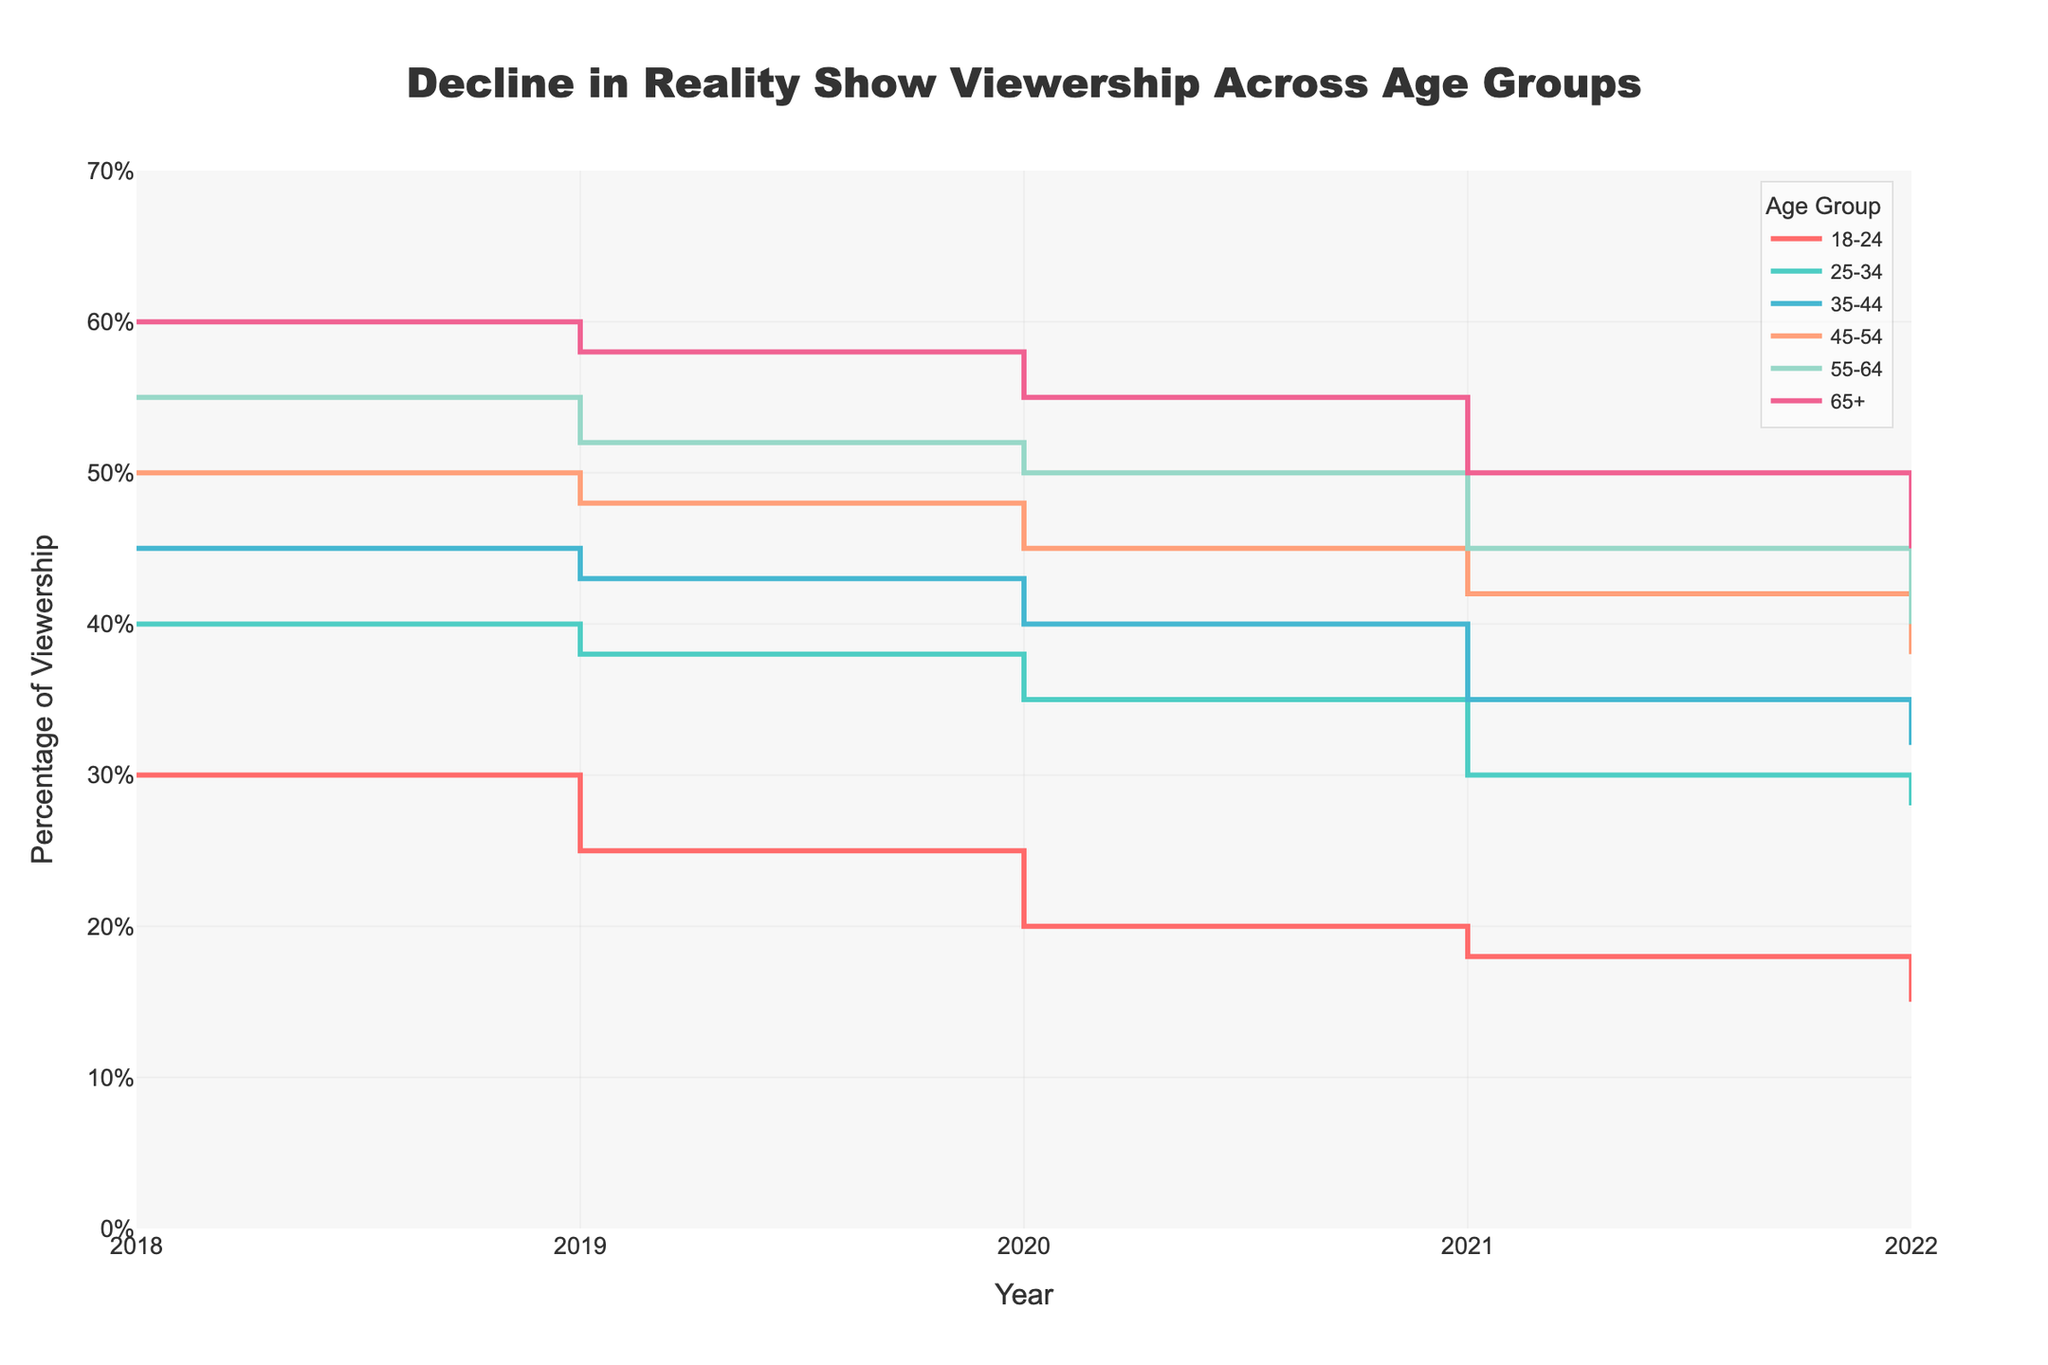What is the title of the figure? The title is located at the top center of the figure.
Answer: Decline in Reality Show Viewership Across Age Groups Which age group had the highest viewership of reality shows in 2018? By examining the data points from 2018, the highest percentage value on the y-axis corresponds to the 65+ age group.
Answer: 65+ How did the viewership percentage for the 18-24 age group change from 2018 to 2022? Look at the y-values for the 18-24 age group from 2018 to 2022. The viewership went down from 30% to 15%.
Answer: Decreased by 15% Which age group saw the smallest change in viewership from 2018 to 2022? Observe the trend lines for each age group from 2018 to 2022. The 65+ group changed from 60% in 2018 to 45% in 2022, a difference of 15 percentage points, which appears to be the smallest change.
Answer: 65+ What is the average viewership percentage for the 25-34 age group over the years 2019 to 2021? Sum the percentages for the 25-34 age group from 2019 to 2021 and divide by the number of years (38 + 35 + 30) / 3.
Answer: 34.33% Between which two consecutive years did the 35-44 age group experience the largest drop in viewership? Compare the drop in viewership percentages between consecutive years. The largest drop for the 35-44 age group is from 2018 (45%) to 2019 (43%), resulting in a decrease of 10 percentage points between 2019 and 2020.
Answer: 2019-2020 Has any age group increased its viewership percentage for reality shows from 2018 to 2022? Look at the trend lines for each age group. All age groups show a decline by 2022. None of the lines trend upwards overall from 2018 to 2022.
Answer: No What age group had the largest percentage viewership in reality shows in 2020, and what was the percentage? Look at the y-value for each age group in the year 2020. The highest percentage is for the 65+ group with 55%.
Answer: 65+, 55% Which age group experienced the most steeper decline in viewership from 2018 to 2022? By observing the trend lines, the steepest decline is seen in the lines with the greatest slope. Both the 18-24 and 65+ groups experienced the same steepest decline of 15 percentage points over the years: 30% to 15% and 60% to 45%, respectively.
Answer: 18-24 and 65+ Which year had the highest viewership percentages overall for reality shows across all age groups? Summing the percentages for each year and comparing them. 2018 appears to have the highest combined total viewership for all age groups.
Answer: 2018 